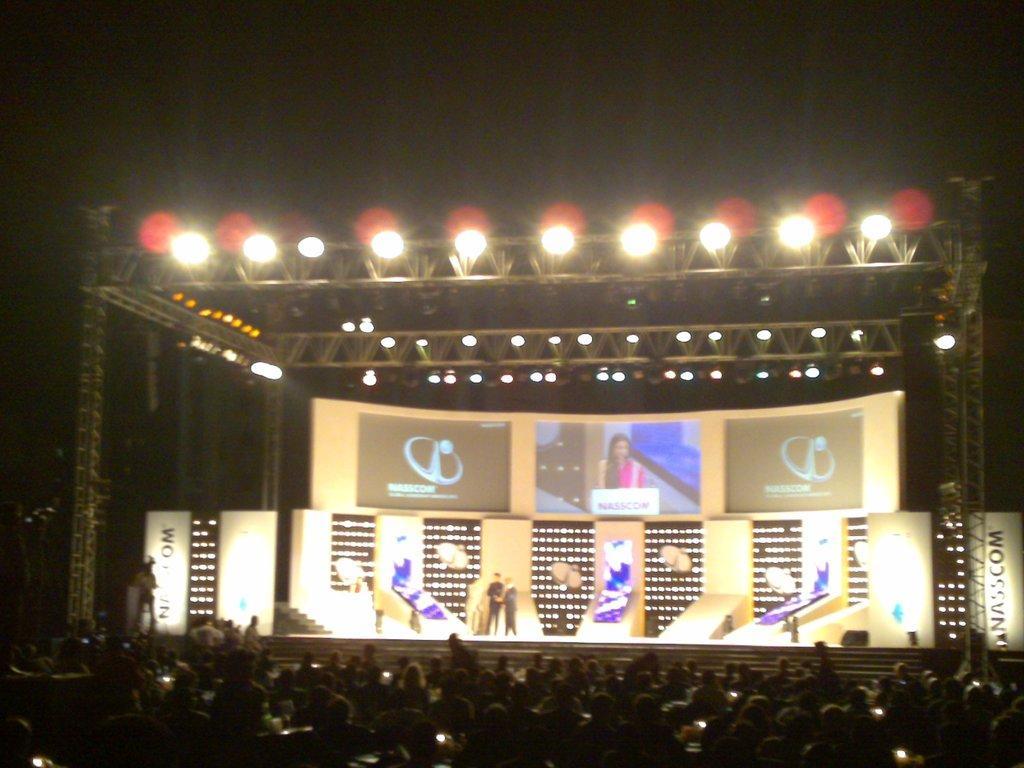Can you describe this image briefly? As we can see in the image there are group of people here and there, banners and lights. The image is little dark. 